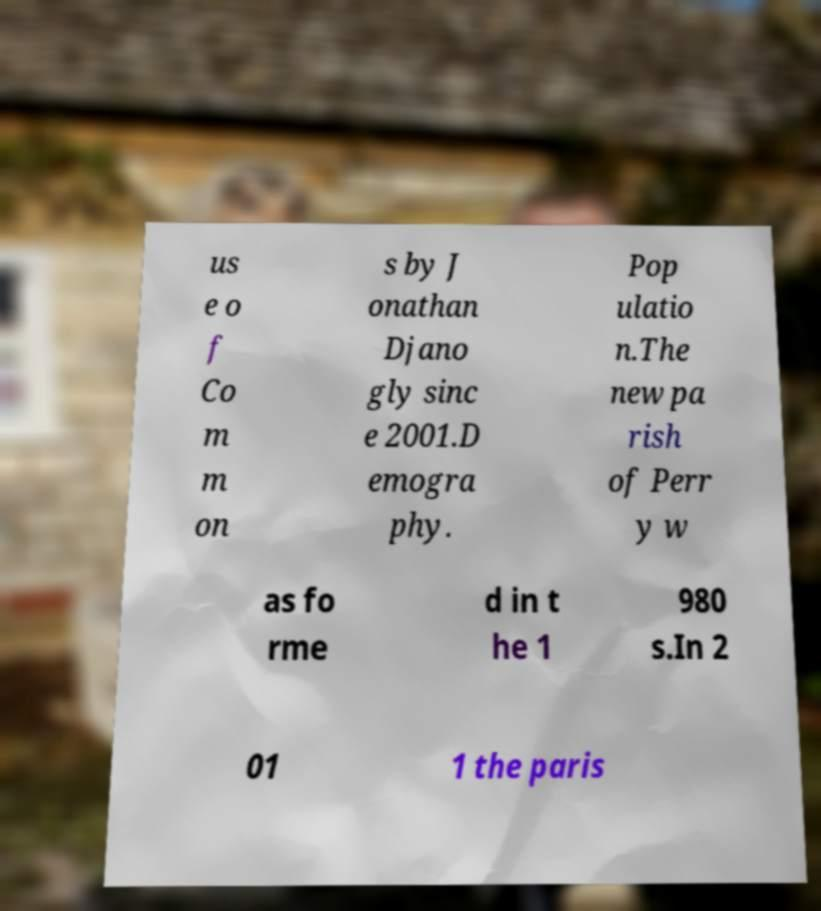Could you extract and type out the text from this image? us e o f Co m m on s by J onathan Djano gly sinc e 2001.D emogra phy. Pop ulatio n.The new pa rish of Perr y w as fo rme d in t he 1 980 s.In 2 01 1 the paris 